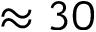Convert formula to latex. <formula><loc_0><loc_0><loc_500><loc_500>\approx 3 0</formula> 